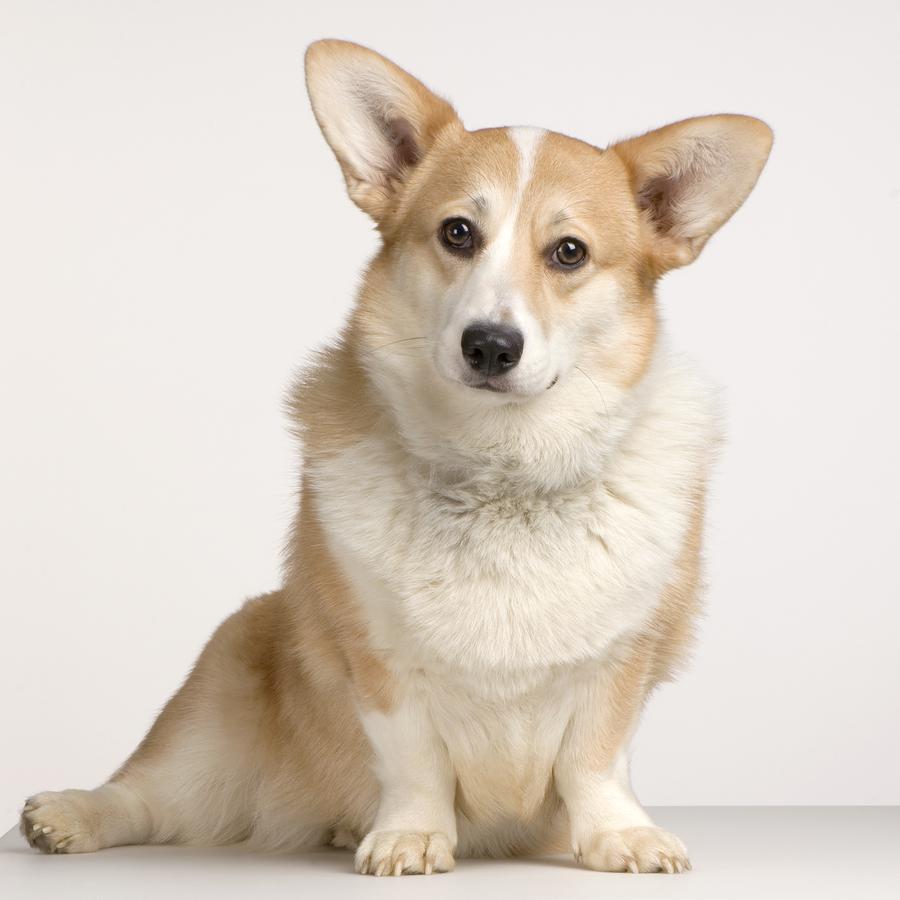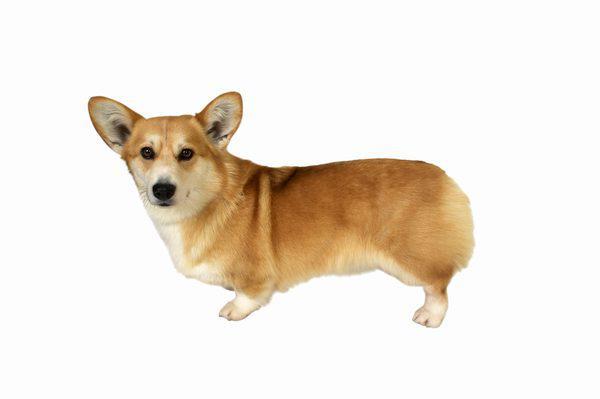The first image is the image on the left, the second image is the image on the right. Given the left and right images, does the statement "In one of the image there is a dog standing in the grass." hold true? Answer yes or no. No. The first image is the image on the left, the second image is the image on the right. Evaluate the accuracy of this statement regarding the images: "There are two dogs with tongue sticking out.". Is it true? Answer yes or no. No. The first image is the image on the left, the second image is the image on the right. Assess this claim about the two images: "The image on the right has one dog with a collar exposed.". Correct or not? Answer yes or no. No. The first image is the image on the left, the second image is the image on the right. Given the left and right images, does the statement "An image shows a corgi with body turned leftward on a white background." hold true? Answer yes or no. Yes. 